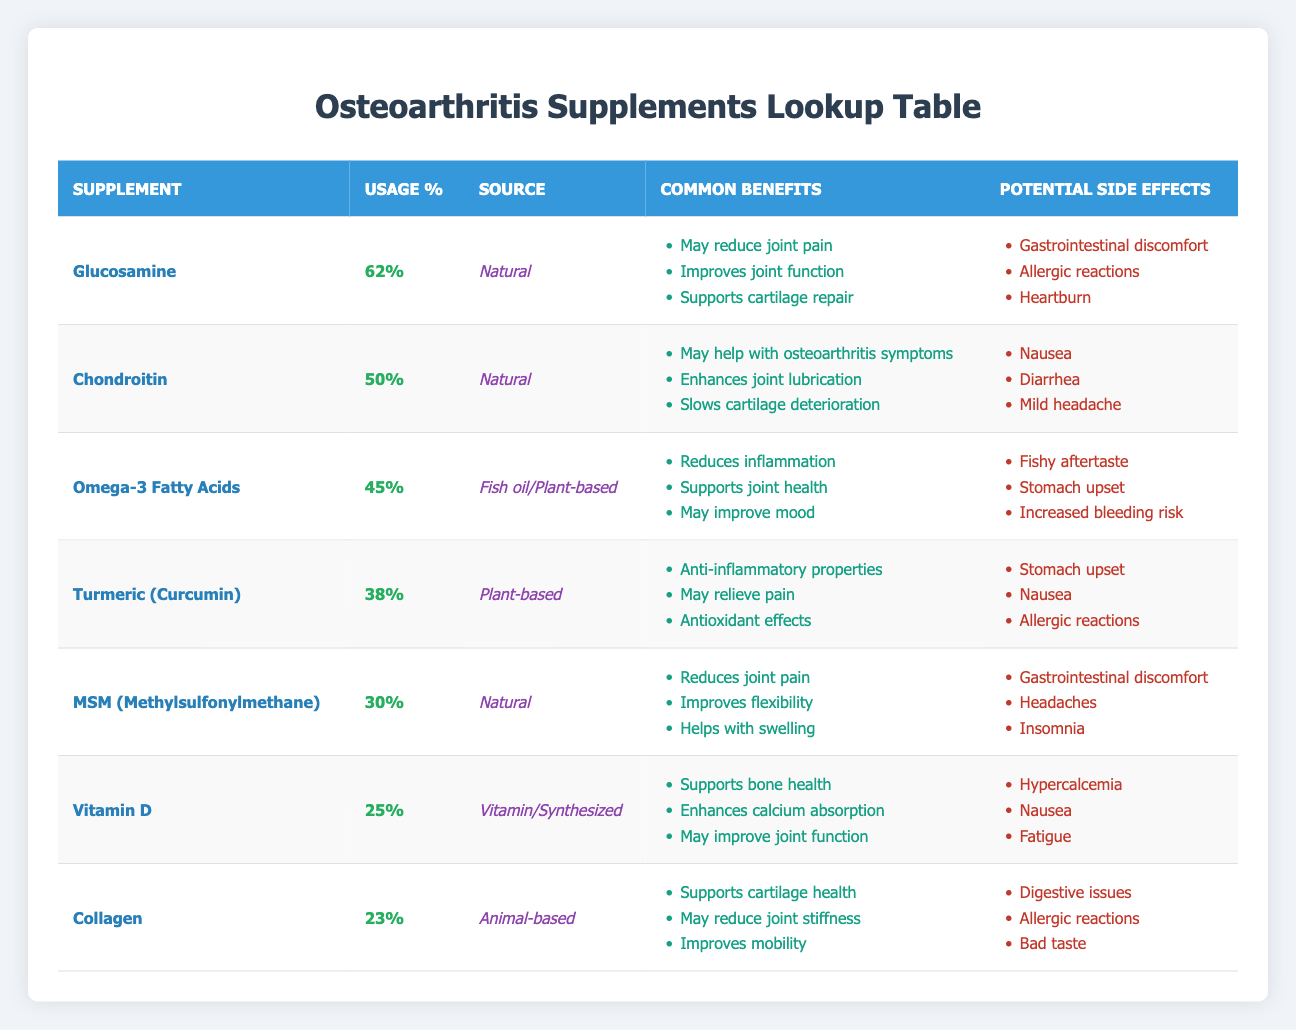What is the percentage of people using Glucosamine? The table shows that the usage percentage for Glucosamine is directly listed as 62%.
Answer: 62% Which supplement has the highest usage percentage? Glucosamine is listed with the highest usage percentage of 62%.
Answer: Glucosamine How many supplements have a usage percentage of less than 30%? The table lists Vitamin D (25%) and Collagen (23%), both of which are less than 30%. Therefore, there are two supplements that meet this criterion.
Answer: 2 What are the common benefits of Chondroitin? The common benefits listed for Chondroitin in the table are: may help with osteoarthritis symptoms, enhances joint lubrication, and slows cartilage deterioration.
Answer: May help with osteoarthritis symptoms, enhances joint lubrication, slows cartilage deterioration Is there any supplement that has potential side effects of nausea? Yes, both Chondroitin and Turmeric have nausea listed as a potential side effect.
Answer: Yes Which two supplements have the lowest usage percentages, and what are those percentages? The supplements with the lowest usage percentages are Collagen (23%) and Vitamin D (25%).
Answer: Collagen (23%), Vitamin D (25%) What is the average usage percentage of the supplements listed? To find the average, sum the usage percentages: (62 + 50 + 45 + 38 + 30 + 25 + 23) = 273. There are 7 supplements, so the average is 273/7 = approximately 39%.
Answer: 39% Does Omega-3 Fatty Acids have more usage percentage than Turmeric? Yes, Omega-3 Fatty Acids has a usage percentage of 45%, which is greater than Turmeric's 38%.
Answer: Yes What common benefit do both MSM and Glucosamine share? Both MSM and Glucosamine have "reduces joint pain" listed as a common benefit.
Answer: Reduces joint pain 